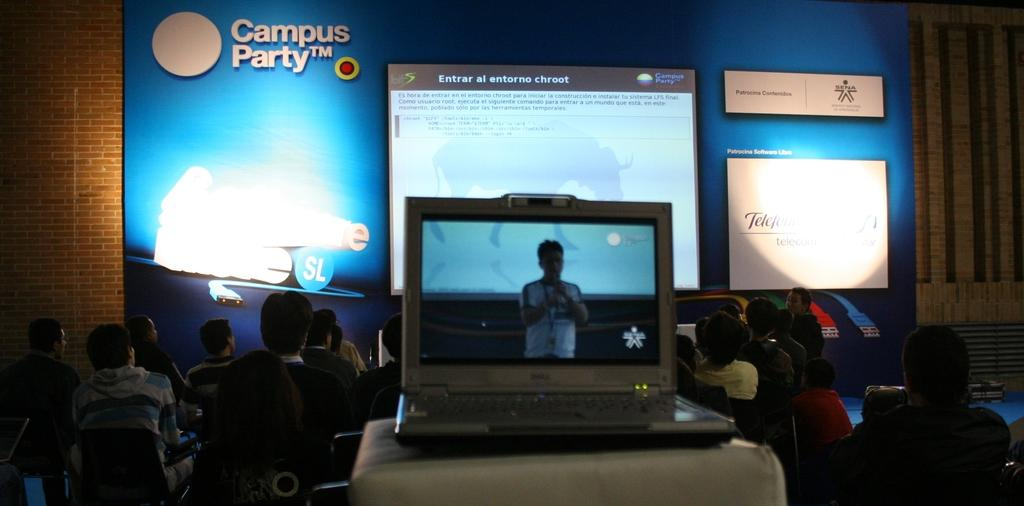<image>
Provide a brief description of the given image. People sitting by a wall that says Campus Party oni t. 